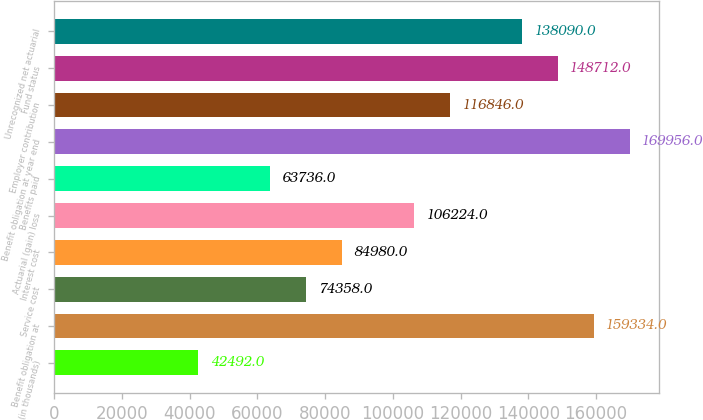<chart> <loc_0><loc_0><loc_500><loc_500><bar_chart><fcel>(in thousands)<fcel>Benefit obligation at<fcel>Service cost<fcel>Interest cost<fcel>Actuarial (gain) loss<fcel>Benefits paid<fcel>Benefit obligation at year end<fcel>Employer contribution<fcel>Fund status<fcel>Unrecognized net actuarial<nl><fcel>42492<fcel>159334<fcel>74358<fcel>84980<fcel>106224<fcel>63736<fcel>169956<fcel>116846<fcel>148712<fcel>138090<nl></chart> 